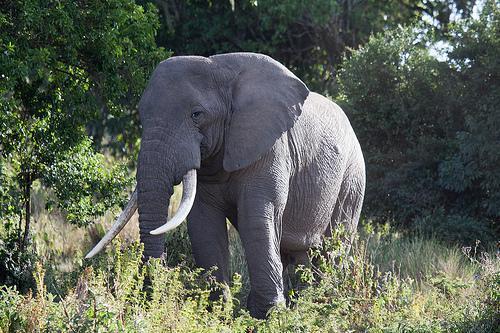How many elephants in the phot?
Give a very brief answer. 1. 